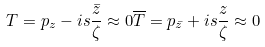Convert formula to latex. <formula><loc_0><loc_0><loc_500><loc_500>T = p _ { z } - i s \frac { \bar { z } } { \zeta } \approx 0 \overline { T } = p _ { \bar { z } } + i s \frac { z } { \zeta } \approx 0</formula> 